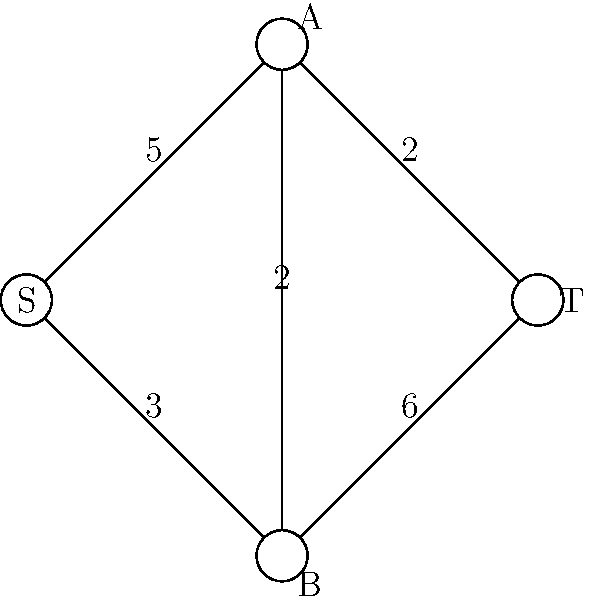Given the network flow diagram representing potential goal-scoring paths against Sheffield Wednesday's defense, what is the maximum flow from source (S) to target (T)? Each edge is labeled with its capacity. To find the maximum flow from S to T, we'll use the Ford-Fulkerson algorithm:

1. Initialize flow to 0.

2. Find augmenting paths from S to T:
   a) Path S-A-T: min(5,2) = 2
      Flow = 0 + 2 = 2
   b) Path S-B-T: min(3,6) = 3
      Flow = 2 + 3 = 5
   c) Path S-A-B-T: min(5-2, 2, 6-3) = 1
      Flow = 5 + 1 = 6
   d) Path S-B-A-T: min(3-3, 2, 2-2) = 0
      No more augmenting paths.

3. The maximum flow is the sum of all flow increases: 2 + 3 + 1 = 6.

This represents the maximum number of goal-scoring opportunities that can be created against Sheffield Wednesday's defense given the network constraints.
Answer: 6 